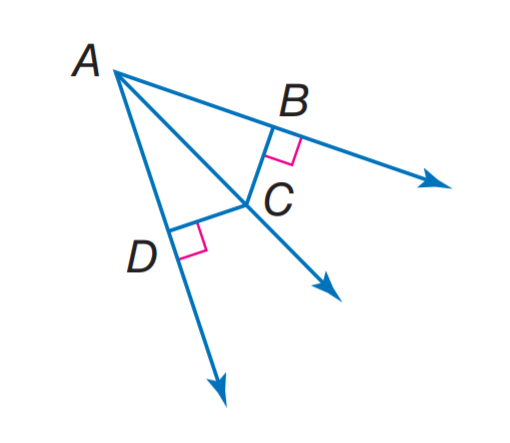Answer the mathemtical geometry problem and directly provide the correct option letter.
Question: m \angle B A C = 40, m \angle D A C = 40, and D C = 10, find B C.
Choices: A: 10 B: 20 C: 30 D: 40 A 